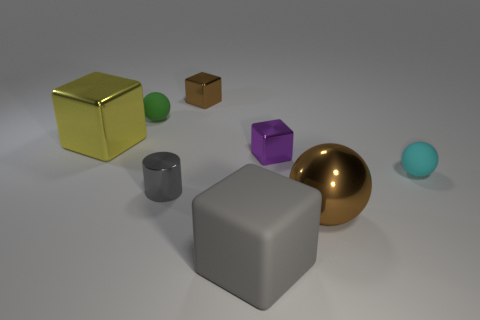Subtract all green matte spheres. How many spheres are left? 2 Subtract all balls. How many objects are left? 5 Subtract all green balls. How many balls are left? 2 Add 1 tiny gray cylinders. How many objects exist? 9 Subtract all purple blocks. Subtract all blue rubber cylinders. How many objects are left? 7 Add 7 yellow blocks. How many yellow blocks are left? 8 Add 2 cyan spheres. How many cyan spheres exist? 3 Subtract 1 brown blocks. How many objects are left? 7 Subtract 1 cubes. How many cubes are left? 3 Subtract all cyan balls. Subtract all brown cubes. How many balls are left? 2 